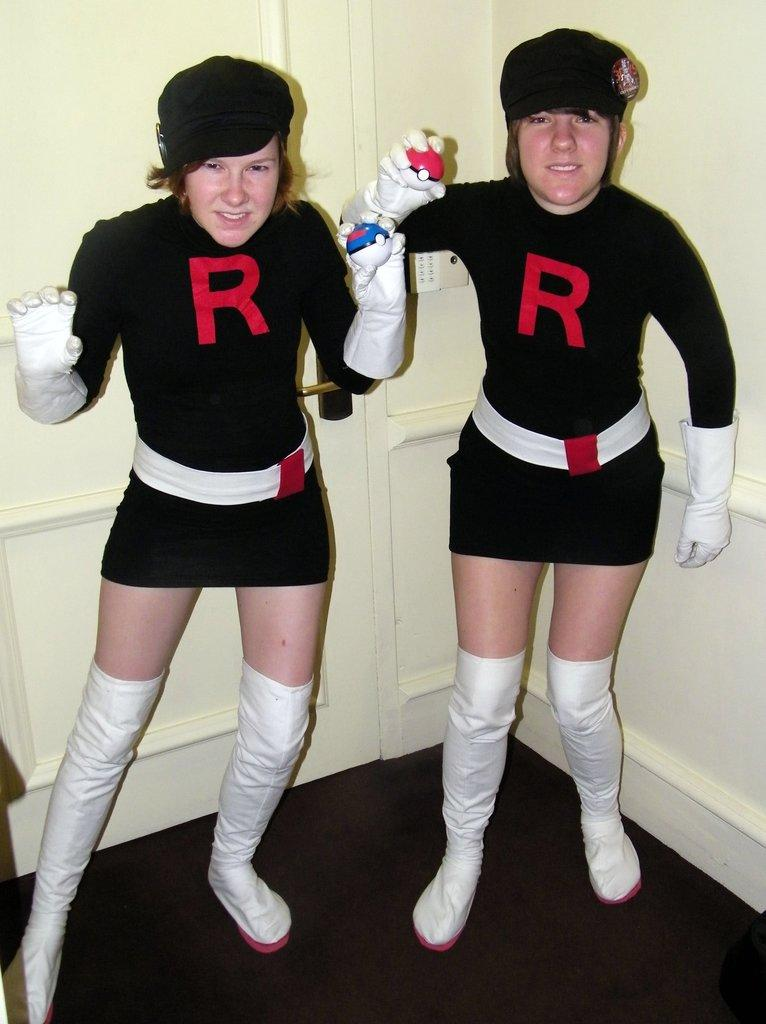<image>
Offer a succinct explanation of the picture presented. Two girls are in costumes that have the letter R on the top. 